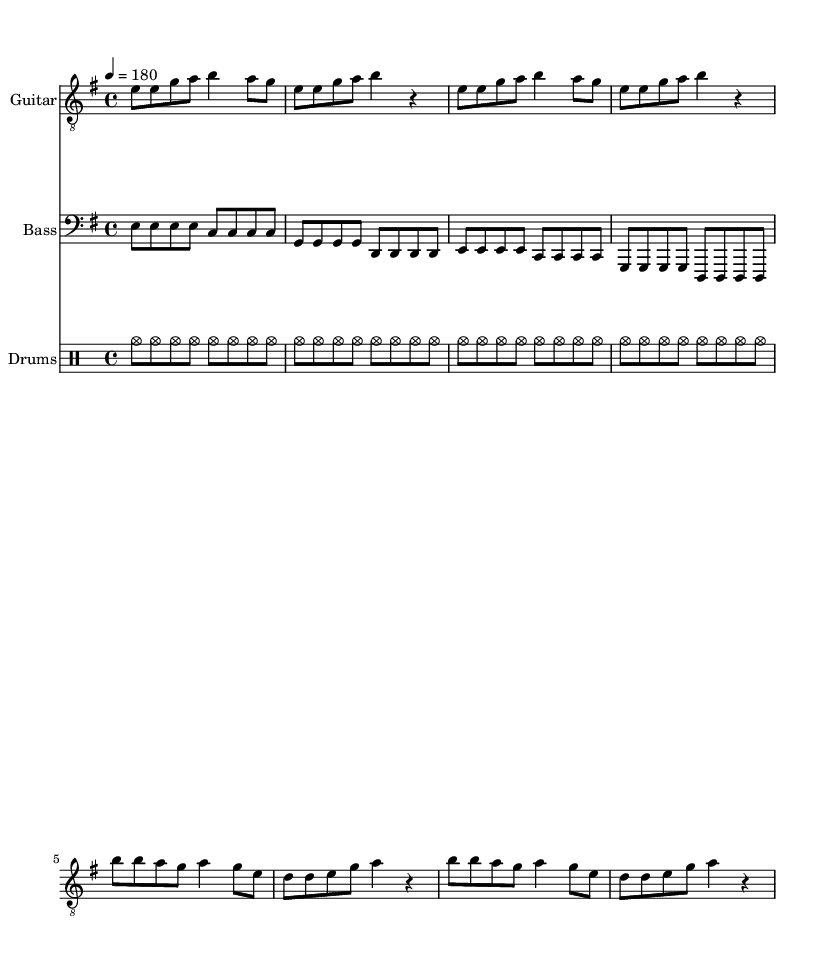What is the key signature of this music? The key signature is indicated by the two sharps in the notation, which corresponds to the key of E minor.
Answer: E minor What is the time signature of this music? The time signature, shown at the beginning of the piece, is 4/4, meaning there are four beats in each measure, and the quarter note gets one beat.
Answer: 4/4 What is the tempo marking for this music? The tempo marking indicates a speed of 180 beats per minute, which suggests a fast and energetic feel typical of punk music.
Answer: 180 How many measures are there in the verse section? The verse section consists of two repeated musical phrases, each lasting four measures, totaling eight measures overall.
Answer: 8 What key components are present in the chorus section? The chorus features a repeated rhythmic and melodic pattern emphasizing the lyrics about ethical dilemmas, a common theme in punk anthems.
Answer: Ethical dilemma What instruments are used in this punk anthem? The music features three specific instruments: guitar, bass, and drums, which are essential for a traditional punk sound.
Answer: Guitar, bass, drums What is a notable lyrical theme in the song? The lyrics address themes of consent and ethical dilemmas, reflecting on the complexities of medical research, which resonates with punk's critical stance on societal issues.
Answer: Ethical dilemma 